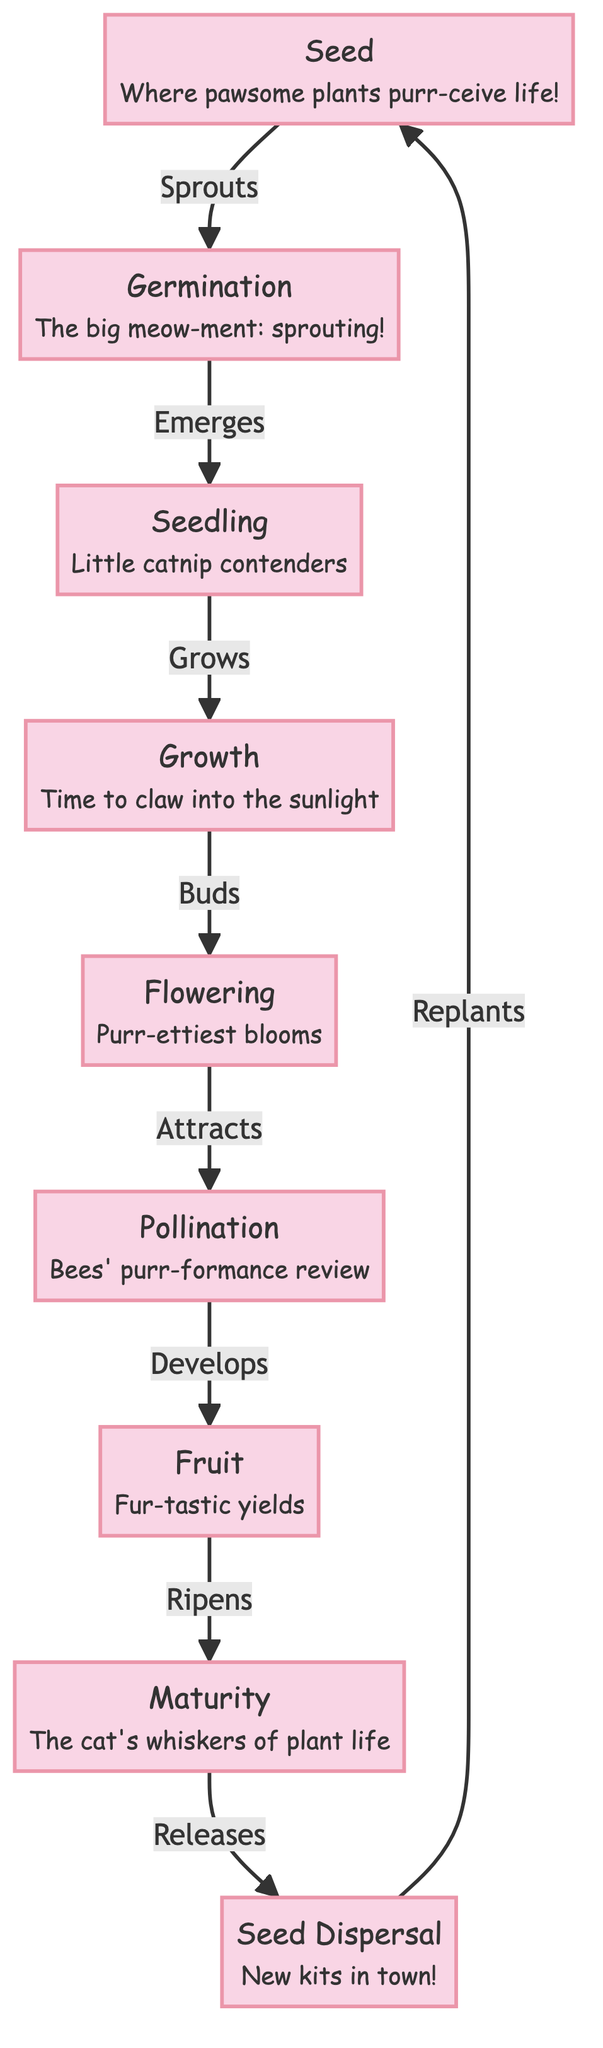What's the first stage in the plant life cycle? The diagram starts with the "Seed" stage, which is indicated as the first node in the flowchart. It describes where life begins for the plants.
Answer: Seed How many total stages are there in the plant life cycle? The diagram lists nine distinct stages of the plant life cycle, from "Seed" to "Seed Dispersal." Counting these nodes gives a total of nine stages.
Answer: 9 What is the relationship between germination and seedling? The diagram shows that "Germination" leads to "Seedling." This is indicated by the arrow labeled "Emerges." This means that seed germination results in the emergence of seedlings.
Answer: Emerges What humorous note is associated with the flowering stage? The "Flowering" stage has the annotation "Purr-ettiest blooms," which adds a playful, pun-filled element to the diagram referring to its beauty.
Answer: Purr-ettiest blooms What stage comes after fruit? According to the flow of the diagram, "Maturity" comes after "Fruit," confirming the progression in the life cycle after the fruits have developed and ripened.
Answer: Maturity Which stage is referred to as "the cat's whiskers of plant life"? The "Maturity" stage is humorously annotated as "the cat's whiskers of plant life," emphasizing an important phase in a plant's life cycle with a cat-related pun.
Answer: the cat's whiskers of plant life What action is described between pollination and fruit? The arrow from "Pollination" to "Fruit" is labeled "Develops," indicating the action that takes place when flowers are pollinated, leading to the development of fruit.
Answer: Develops What can be inferred about seed dispersal? The "Seed Dispersal" stage notes "New kits in town!" This suggests that the dispersal of seeds is akin to having new kittens or plants establishing themselves in new locations.
Answer: New kits in town! Which stage is the end of the life cycle before dispersal? The "Maturity" stage is identified before the final stage of "Seed Dispersal." It marks the transition to the dispersal of seeds to begin the cycle anew.
Answer: Maturity 